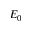<formula> <loc_0><loc_0><loc_500><loc_500>E _ { 0 }</formula> 